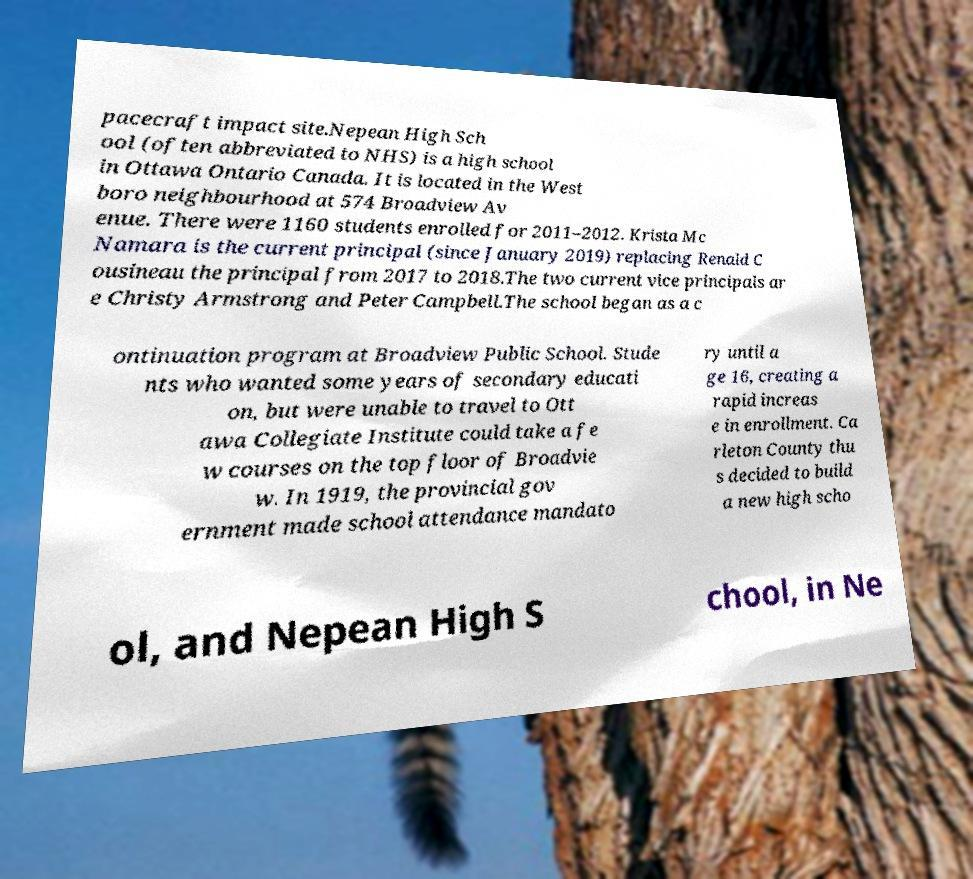Please identify and transcribe the text found in this image. pacecraft impact site.Nepean High Sch ool (often abbreviated to NHS) is a high school in Ottawa Ontario Canada. It is located in the West boro neighbourhood at 574 Broadview Av enue. There were 1160 students enrolled for 2011–2012. Krista Mc Namara is the current principal (since January 2019) replacing Renald C ousineau the principal from 2017 to 2018.The two current vice principals ar e Christy Armstrong and Peter Campbell.The school began as a c ontinuation program at Broadview Public School. Stude nts who wanted some years of secondary educati on, but were unable to travel to Ott awa Collegiate Institute could take a fe w courses on the top floor of Broadvie w. In 1919, the provincial gov ernment made school attendance mandato ry until a ge 16, creating a rapid increas e in enrollment. Ca rleton County thu s decided to build a new high scho ol, and Nepean High S chool, in Ne 